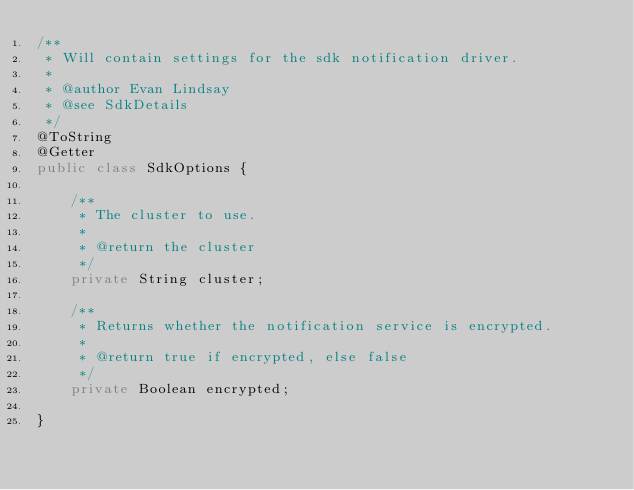Convert code to text. <code><loc_0><loc_0><loc_500><loc_500><_Java_>/**
 * Will contain settings for the sdk notification driver.
 *
 * @author Evan Lindsay
 * @see SdkDetails
 */
@ToString
@Getter
public class SdkOptions {

    /**
     * The cluster to use.
     *
     * @return the cluster
     */
    private String cluster;

    /**
     * Returns whether the notification service is encrypted.
     *
     * @return true if encrypted, else false
     */
    private Boolean encrypted;

}
</code> 